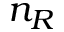<formula> <loc_0><loc_0><loc_500><loc_500>n _ { R }</formula> 